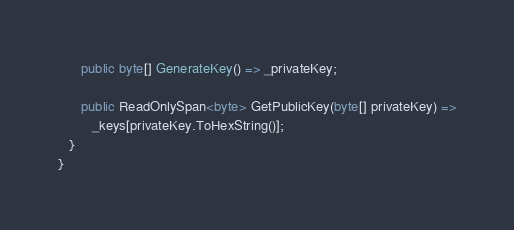<code> <loc_0><loc_0><loc_500><loc_500><_C#_>
      public byte[] GenerateKey() => _privateKey;

      public ReadOnlySpan<byte> GetPublicKey(byte[] privateKey) =>
         _keys[privateKey.ToHexString()];
   }
}</code> 